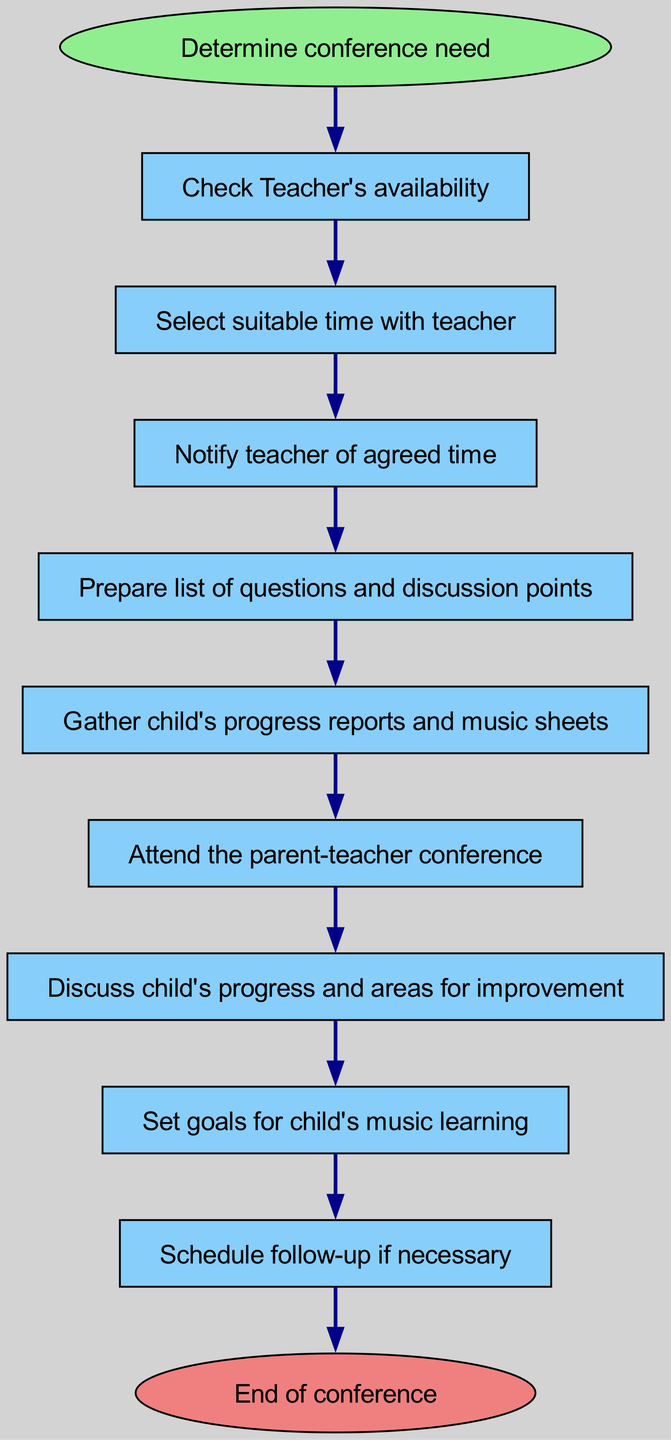What is the first step in the conference process? The diagram indicates that the first step is labeled "Start," which corresponds to "Determine conference need." This sets the context for the following steps.
Answer: Determine conference need How many total steps are in the flow diagram? By counting the nodes in the diagram, we identify that there are 11 steps from "Start" to "End." Each step is represented as a node in the flowchart.
Answer: 11 What does the node "Discuss Progress" lead to? The node "Discuss Progress" directly leads to "Set Goals," indicating that after discussing the child's music progress, the next step is to set specific goals for improvement.
Answer: Set Goals Which step comes after "Notify Teacher"? Following the "Notify Teacher" node, the next node in sequence is "Prepare Questions," indicating that after notifying the teacher, you should prepare for the conference discussion.
Answer: Prepare Questions What is the last action taken in the flow? The last action listed in the diagram is "End," marking the conclusion of the parent-teacher conference process. This signifies that all necessary discussions and plans are finalized.
Answer: End If a follow-up is deemed necessary, which step does that relate to? The step labeled "Follow Up" directly relates to scheduling additional meetings or discussions if the conference indicated further steps were needed regarding the child's music progress.
Answer: Follow Up What actions are taken before attending the conference? Before "Attend Conference," the actions to be taken are "Prepare Questions" and "Gather Materials," indicating that preparation is essential in advance of the actual conference.
Answer: Prepare Questions, Gather Materials How do you conclude the conference? The conclusion of the conference is indicated by the node "End," which is reached after all necessary discussions have taken place and goals set. This marks the closure of the conference.
Answer: End 